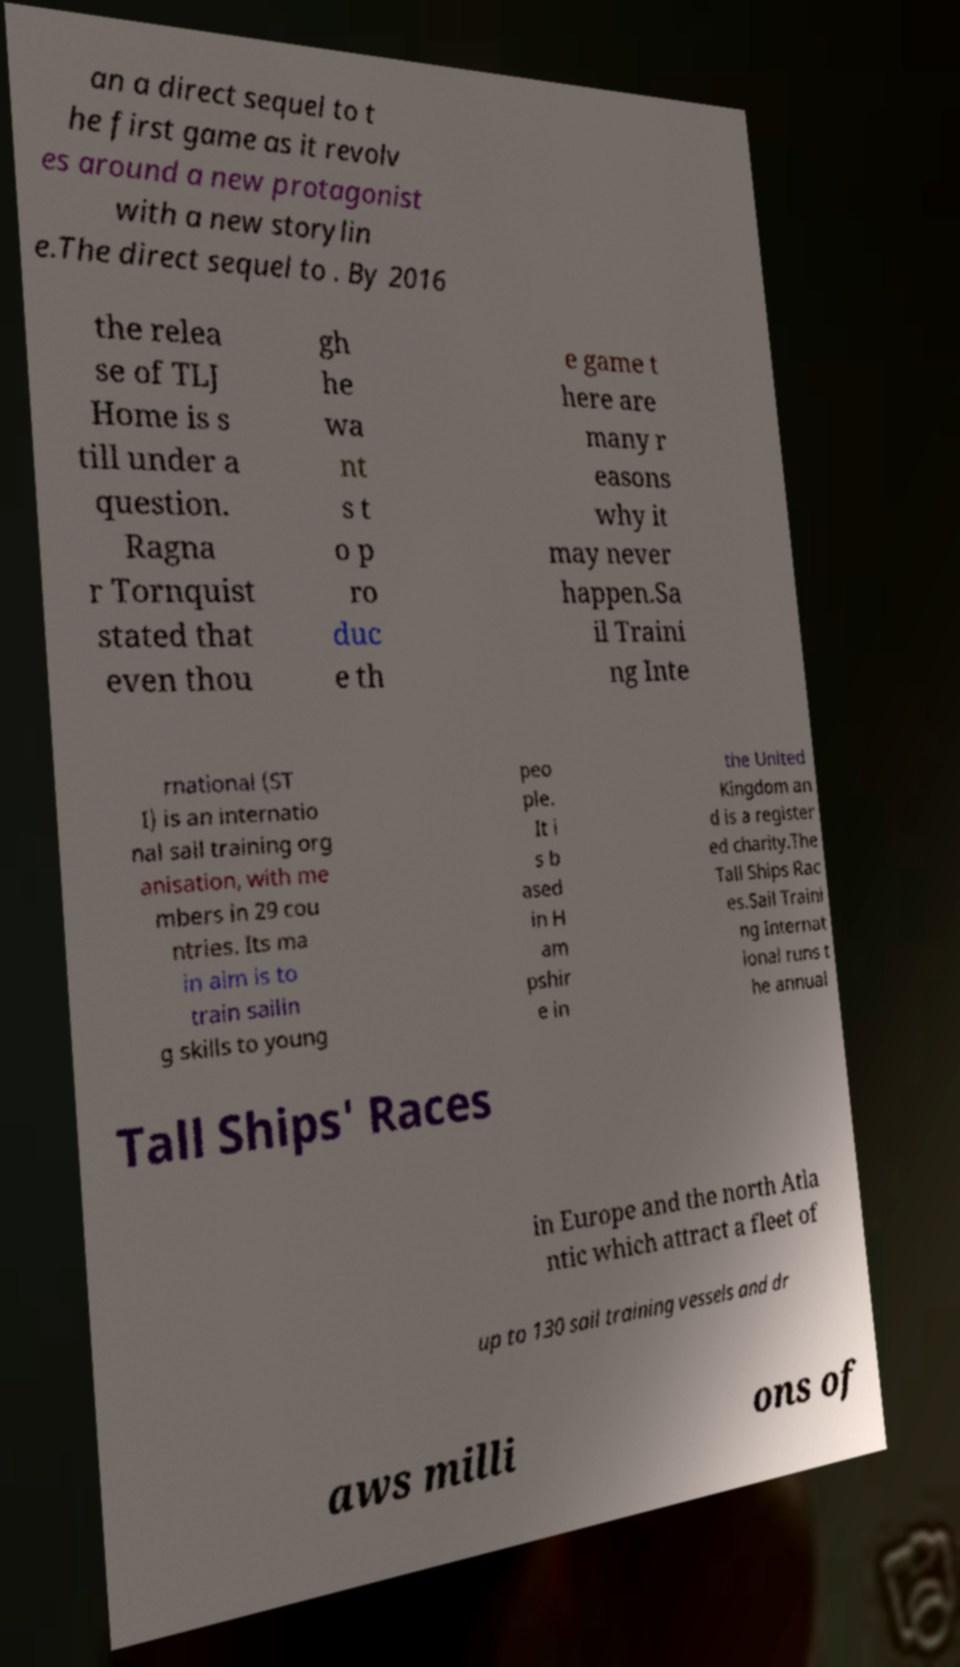Please read and relay the text visible in this image. What does it say? an a direct sequel to t he first game as it revolv es around a new protagonist with a new storylin e.The direct sequel to . By 2016 the relea se of TLJ Home is s till under a question. Ragna r Tornquist stated that even thou gh he wa nt s t o p ro duc e th e game t here are many r easons why it may never happen.Sa il Traini ng Inte rnational (ST I) is an internatio nal sail training org anisation, with me mbers in 29 cou ntries. Its ma in aim is to train sailin g skills to young peo ple. It i s b ased in H am pshir e in the United Kingdom an d is a register ed charity.The Tall Ships Rac es.Sail Traini ng Internat ional runs t he annual Tall Ships' Races in Europe and the north Atla ntic which attract a fleet of up to 130 sail training vessels and dr aws milli ons of 